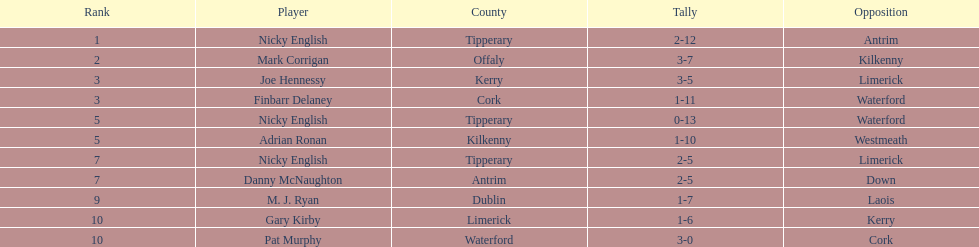How many people are on the list? 9. 